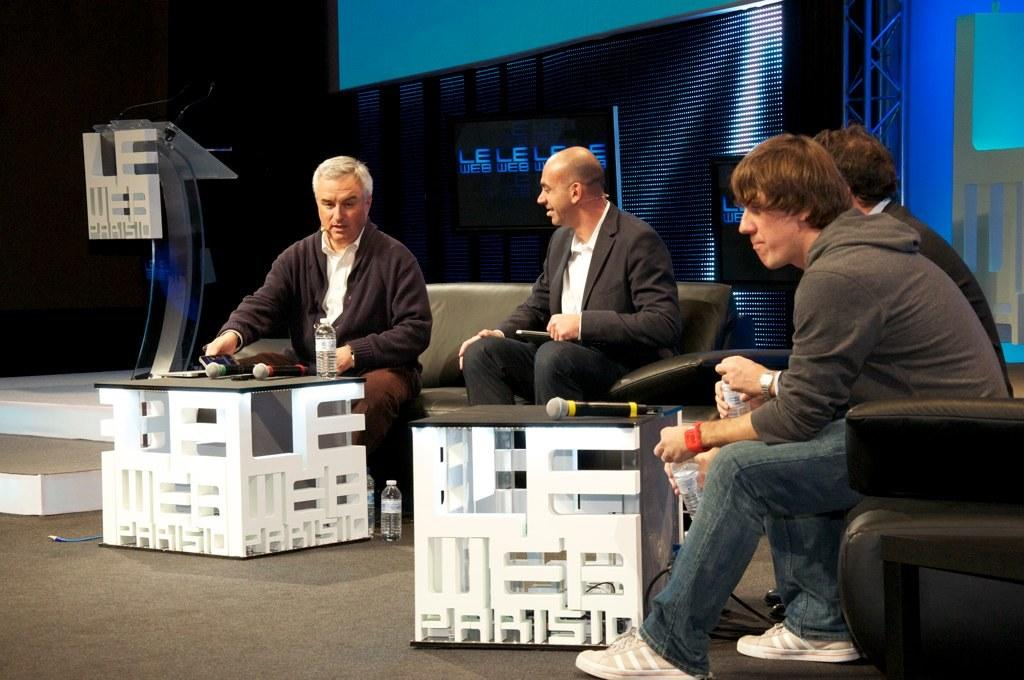<image>
Render a clear and concise summary of the photo. Four men sit near square tables that say Le Web Paris on the sides. 